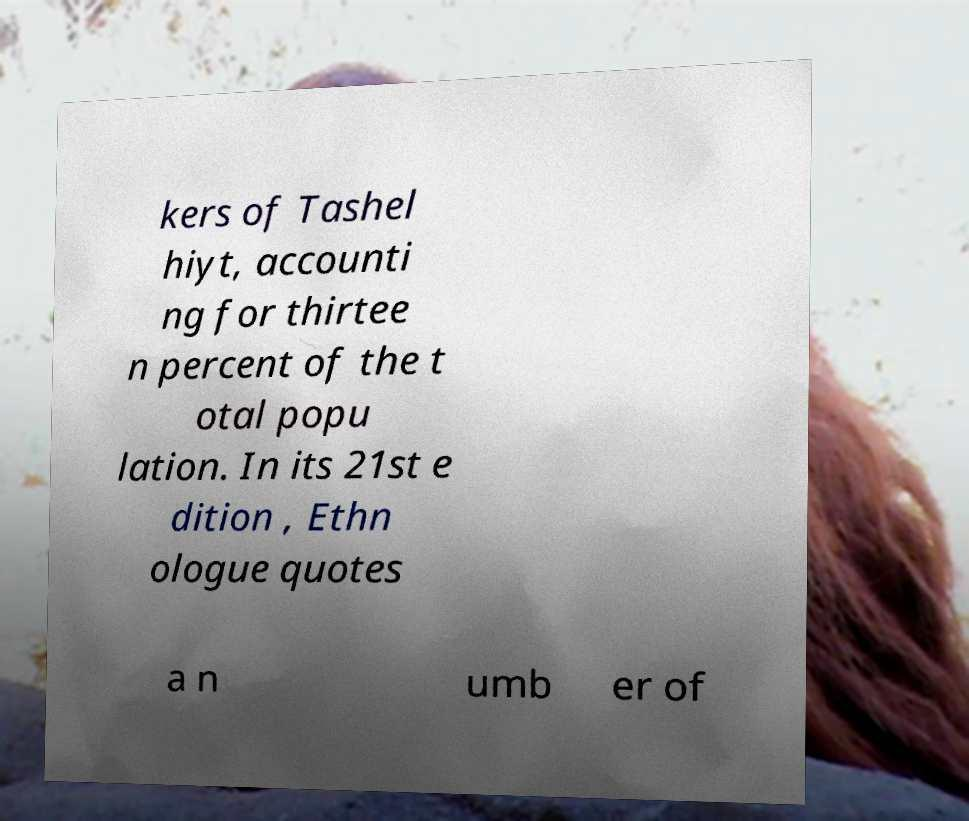Could you assist in decoding the text presented in this image and type it out clearly? kers of Tashel hiyt, accounti ng for thirtee n percent of the t otal popu lation. In its 21st e dition , Ethn ologue quotes a n umb er of 